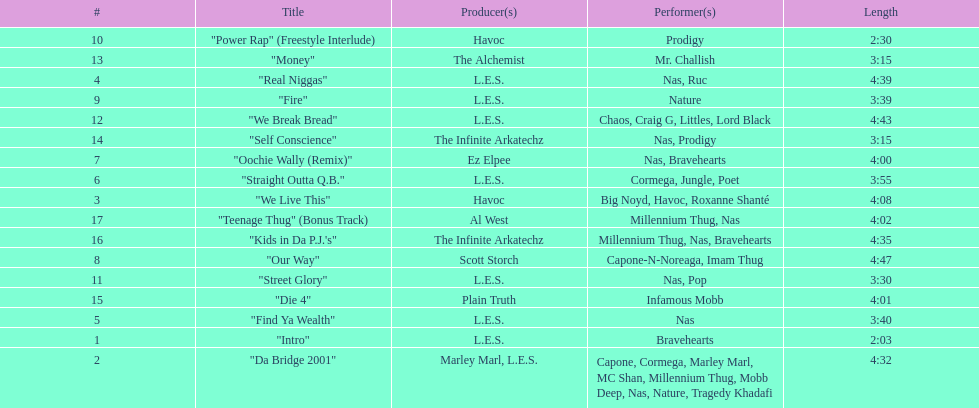Parse the table in full. {'header': ['#', 'Title', 'Producer(s)', 'Performer(s)', 'Length'], 'rows': [['10', '"Power Rap" (Freestyle Interlude)', 'Havoc', 'Prodigy', '2:30'], ['13', '"Money"', 'The Alchemist', 'Mr. Challish', '3:15'], ['4', '"Real Niggas"', 'L.E.S.', 'Nas, Ruc', '4:39'], ['9', '"Fire"', 'L.E.S.', 'Nature', '3:39'], ['12', '"We Break Bread"', 'L.E.S.', 'Chaos, Craig G, Littles, Lord Black', '4:43'], ['14', '"Self Conscience"', 'The Infinite Arkatechz', 'Nas, Prodigy', '3:15'], ['7', '"Oochie Wally (Remix)"', 'Ez Elpee', 'Nas, Bravehearts', '4:00'], ['6', '"Straight Outta Q.B."', 'L.E.S.', 'Cormega, Jungle, Poet', '3:55'], ['3', '"We Live This"', 'Havoc', 'Big Noyd, Havoc, Roxanne Shanté', '4:08'], ['17', '"Teenage Thug" (Bonus Track)', 'Al West', 'Millennium Thug, Nas', '4:02'], ['16', '"Kids in Da P.J.\'s"', 'The Infinite Arkatechz', 'Millennium Thug, Nas, Bravehearts', '4:35'], ['8', '"Our Way"', 'Scott Storch', 'Capone-N-Noreaga, Imam Thug', '4:47'], ['11', '"Street Glory"', 'L.E.S.', 'Nas, Pop', '3:30'], ['15', '"Die 4"', 'Plain Truth', 'Infamous Mobb', '4:01'], ['5', '"Find Ya Wealth"', 'L.E.S.', 'Nas', '3:40'], ['1', '"Intro"', 'L.E.S.', 'Bravehearts', '2:03'], ['2', '"Da Bridge 2001"', 'Marley Marl, L.E.S.', 'Capone, Cormega, Marley Marl, MC Shan, Millennium Thug, Mobb Deep, Nas, Nature, Tragedy Khadafi', '4:32']]} How long is the shortest song on the album? 2:03. 